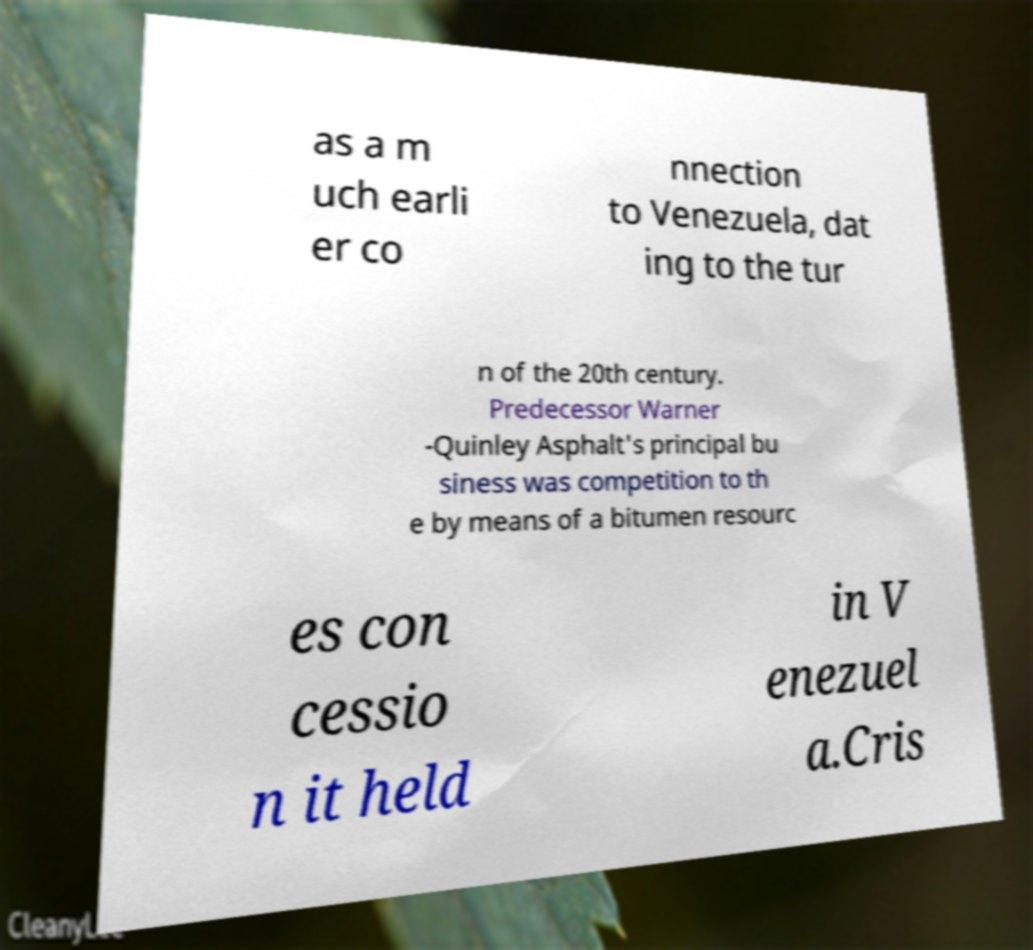Can you read and provide the text displayed in the image?This photo seems to have some interesting text. Can you extract and type it out for me? as a m uch earli er co nnection to Venezuela, dat ing to the tur n of the 20th century. Predecessor Warner -Quinley Asphalt's principal bu siness was competition to th e by means of a bitumen resourc es con cessio n it held in V enezuel a.Cris 